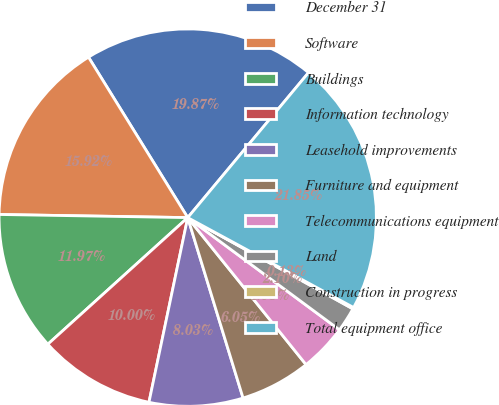<chart> <loc_0><loc_0><loc_500><loc_500><pie_chart><fcel>December 31<fcel>Software<fcel>Buildings<fcel>Information technology<fcel>Leasehold improvements<fcel>Furniture and equipment<fcel>Telecommunications equipment<fcel>Land<fcel>Construction in progress<fcel>Total equipment office<nl><fcel>19.87%<fcel>15.92%<fcel>11.97%<fcel>10.0%<fcel>8.03%<fcel>6.05%<fcel>4.08%<fcel>2.1%<fcel>0.13%<fcel>21.85%<nl></chart> 